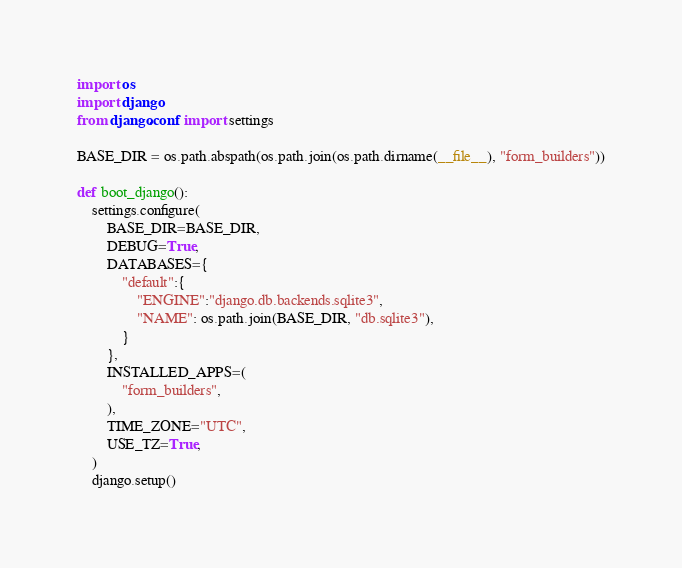Convert code to text. <code><loc_0><loc_0><loc_500><loc_500><_Python_>import os
import django
from django.conf import settings

BASE_DIR = os.path.abspath(os.path.join(os.path.dirname(__file__), "form_builders"))

def boot_django():
    settings.configure(
        BASE_DIR=BASE_DIR,
        DEBUG=True,
        DATABASES={
            "default":{
                "ENGINE":"django.db.backends.sqlite3",
                "NAME": os.path.join(BASE_DIR, "db.sqlite3"),
            }
        },
        INSTALLED_APPS=(
            "form_builders",
        ),
        TIME_ZONE="UTC",
        USE_TZ=True,
    )
    django.setup()
</code> 